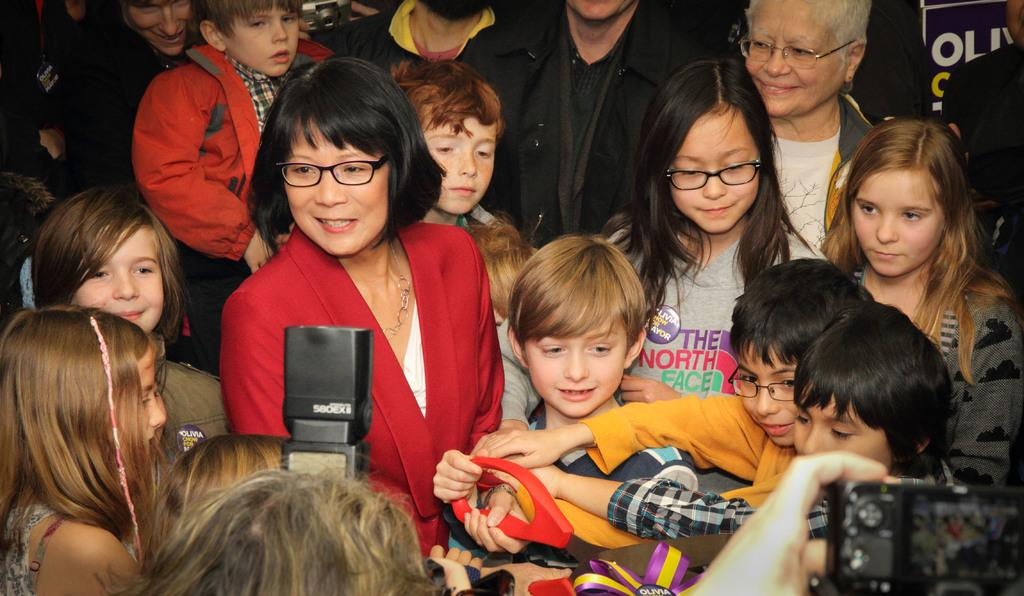What is the main subject of the image? The main subject of the image is a group of persons. Can you describe the composition of the group? There are children in the image, along with other persons. What object is located in the middle of the group? There is a camera in the middle of the group. What color is the object being held by the persons? The object being held by the persons is red. What type of insurance policy is being discussed by the group in the image? There is no indication in the image that the group is discussing any insurance policies. What type of vessel is being used by the group in the image? There is no vessel present in the image; it features a group of persons with a camera and a red object. 